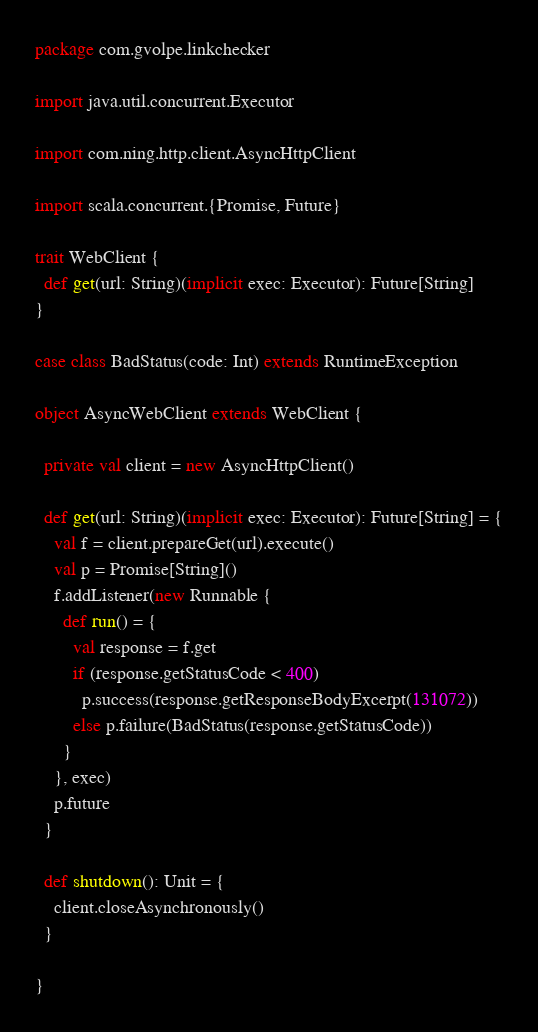Convert code to text. <code><loc_0><loc_0><loc_500><loc_500><_Scala_>package com.gvolpe.linkchecker

import java.util.concurrent.Executor

import com.ning.http.client.AsyncHttpClient

import scala.concurrent.{Promise, Future}

trait WebClient {
  def get(url: String)(implicit exec: Executor): Future[String]
}

case class BadStatus(code: Int) extends RuntimeException

object AsyncWebClient extends WebClient {

  private val client = new AsyncHttpClient()

  def get(url: String)(implicit exec: Executor): Future[String] = {
    val f = client.prepareGet(url).execute()
    val p = Promise[String]()
    f.addListener(new Runnable {
      def run() = {
        val response = f.get
        if (response.getStatusCode < 400)
          p.success(response.getResponseBodyExcerpt(131072))
        else p.failure(BadStatus(response.getStatusCode))
      }
    }, exec)
    p.future
  }

  def shutdown(): Unit = {
    client.closeAsynchronously()
  }

}
</code> 